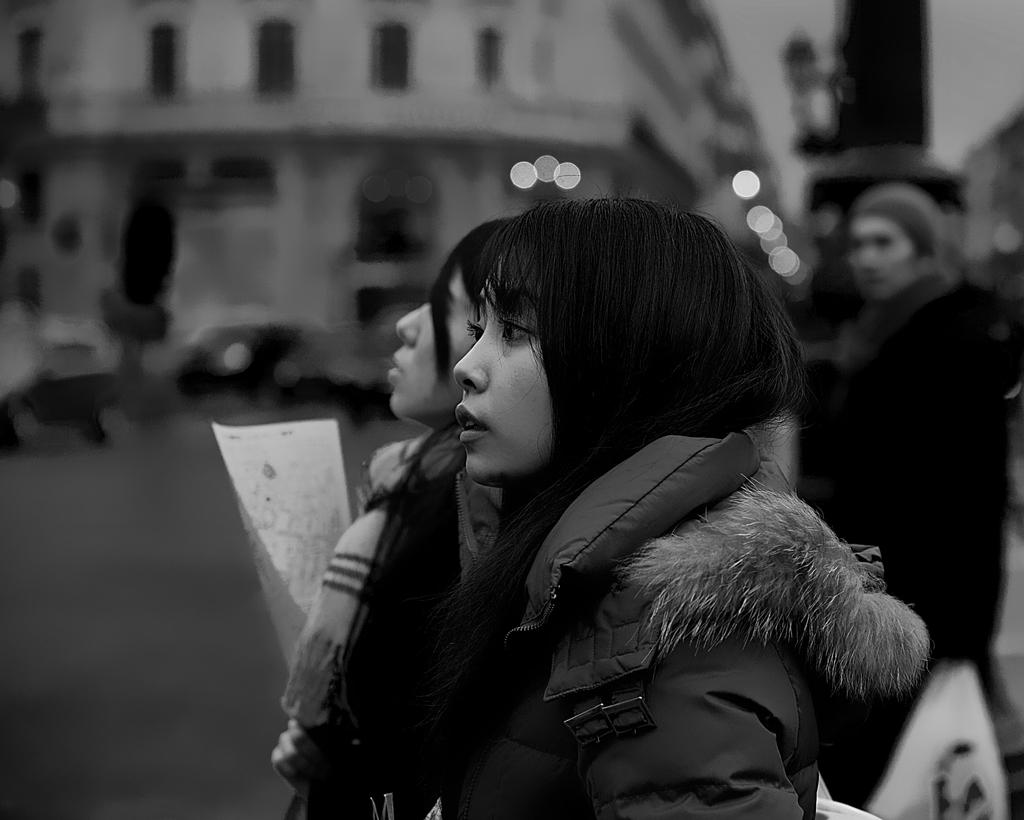What is the color scheme of the image? The image is black and white. How many people are present in the image? There are three persons in the image. What structure can be seen in the image? There is a building in the image. Can you describe the background of the image? The background of the image is blurred. What type of cushion is visible in the image? There is no cushion present in the image. Can you hear a bell ringing in the image? There is no bell present in the image, so it is not possible to hear it ringing. 